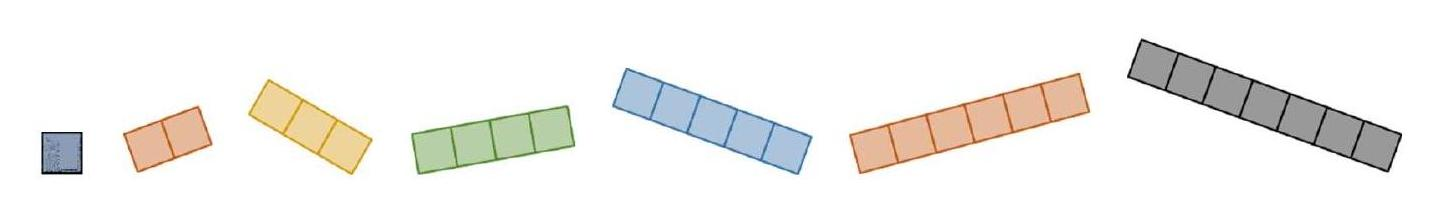How can these pieces be used in educational settings to enhance learning about geometry? These pentomino pieces can be exceptionally useful in educational settings for exploring concepts in geometry such as area, perimeter, and spatial reasoning. Students can manipulate the shapes to fit into predefined areas or create new forms, allowing them to visually and practically understand the properties of geometric shapes and the spatial relationships between them. 